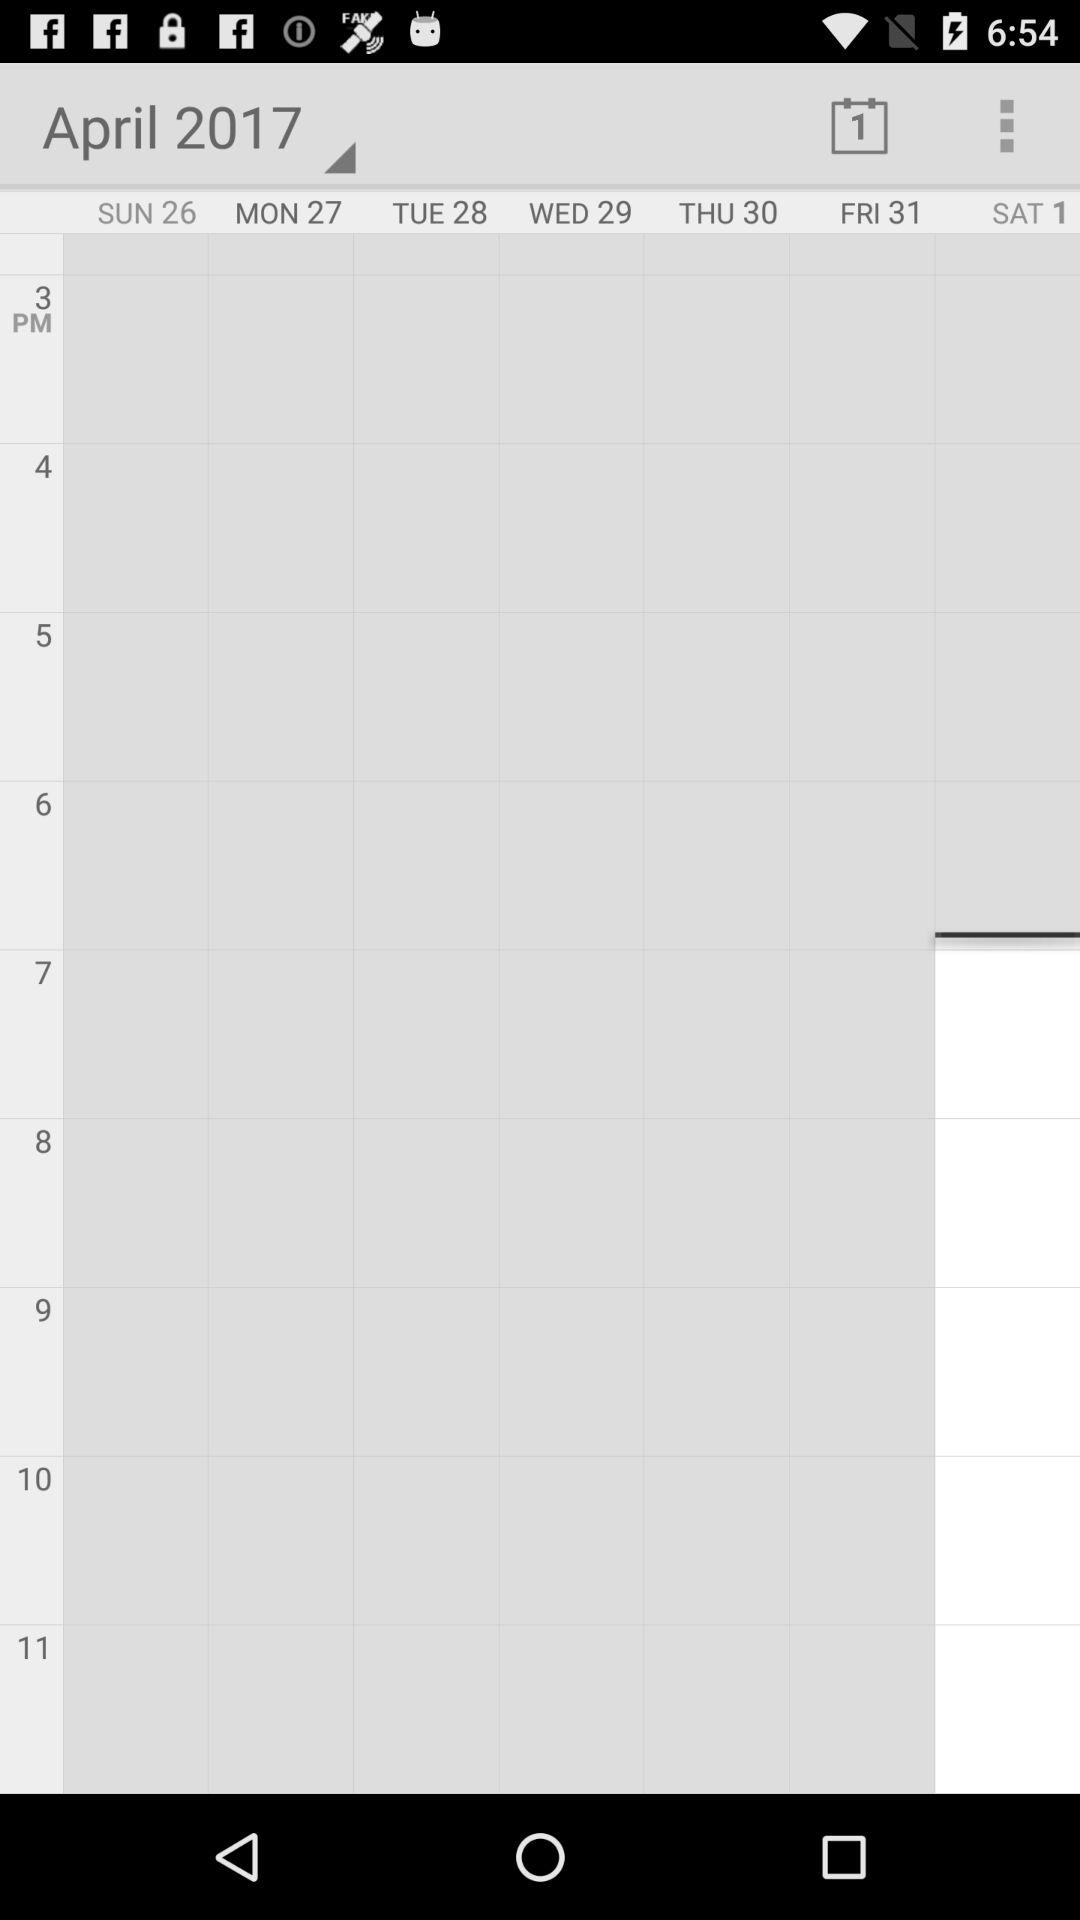What's the month and year in the calendar? The month and year in the calendar are April and 2017, respectively. 